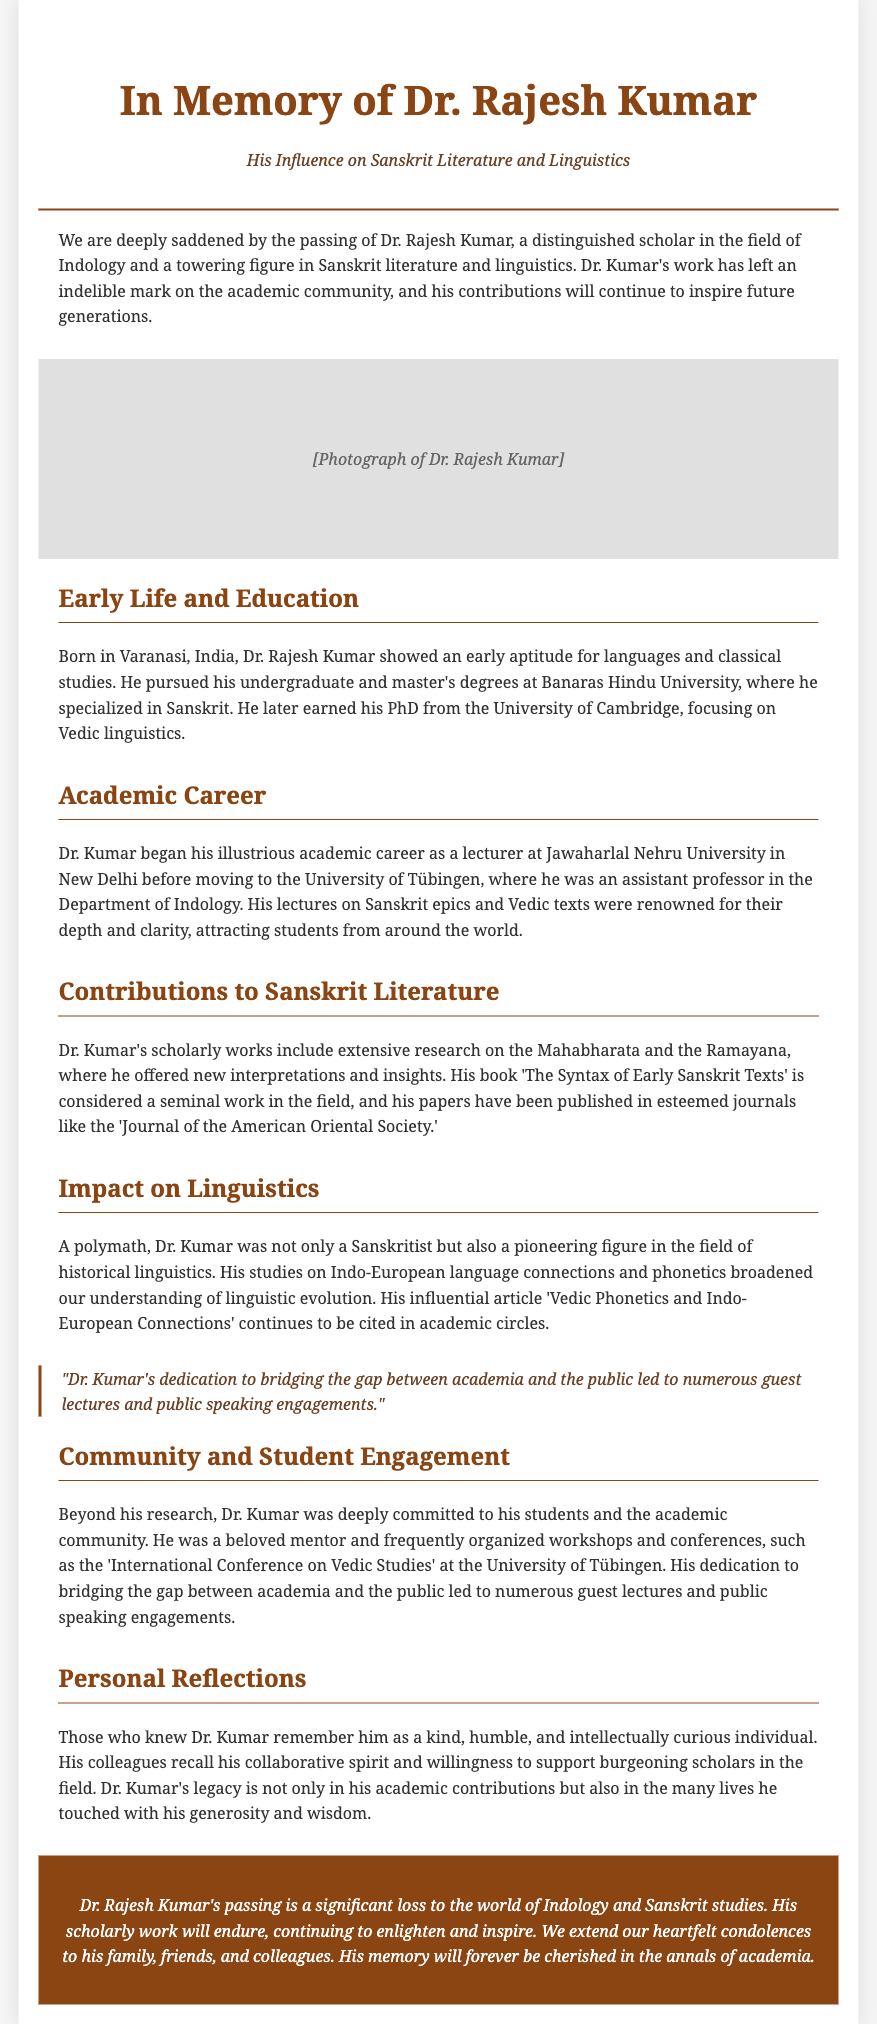What is the title of the obituary? The title is provided at the beginning of the document, which reflects the focus of the tribute.
Answer: In Memory of Dr. Rajesh Kumar Where was Dr. Rajesh Kumar born? This information is located in the section discussing Dr. Kumar's early life and education.
Answer: Varanasi, India What degree did Dr. Kumar earn from the University of Cambridge? The document specifies the focus of Dr. Kumar's PhD in the education section.
Answer: Vedic linguistics What was the name of Dr. Kumar's significant published work? The contributions to Sanskrit literature section mentions a specific book he authored.
Answer: The Syntax of Early Sanskrit Texts Which university did Dr. Kumar teach at before the University of Tübingen? The academic career section indicates where he began his teaching career.
Answer: Jawaharlal Nehru University What did Dr. Kumar's influential article discuss? It is mentioned in the impact on linguistics section, giving insight into its academic focus.
Answer: Vedic Phonetics and Indo-European Connections How did Dr. Kumar contribute to student engagement? The community and student engagement section describes his efforts in this area.
Answer: Workshops and conferences What qualities are remembered about Dr. Kumar? The personal reflections section highlights how colleagues viewed him.
Answer: Kind, humble, and intellectually curious 